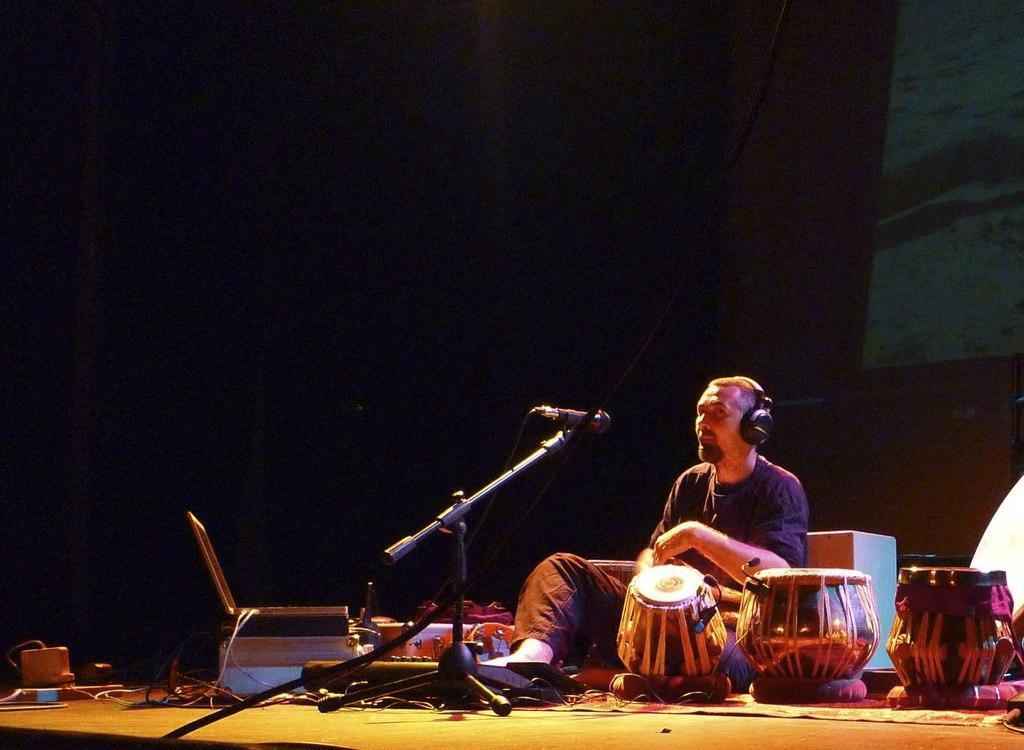Please provide a concise description of this image. In this image, we can see a person sitting. We can see some musical instruments, a microphone and some devices on the ground. We can also see a dark colored background. 